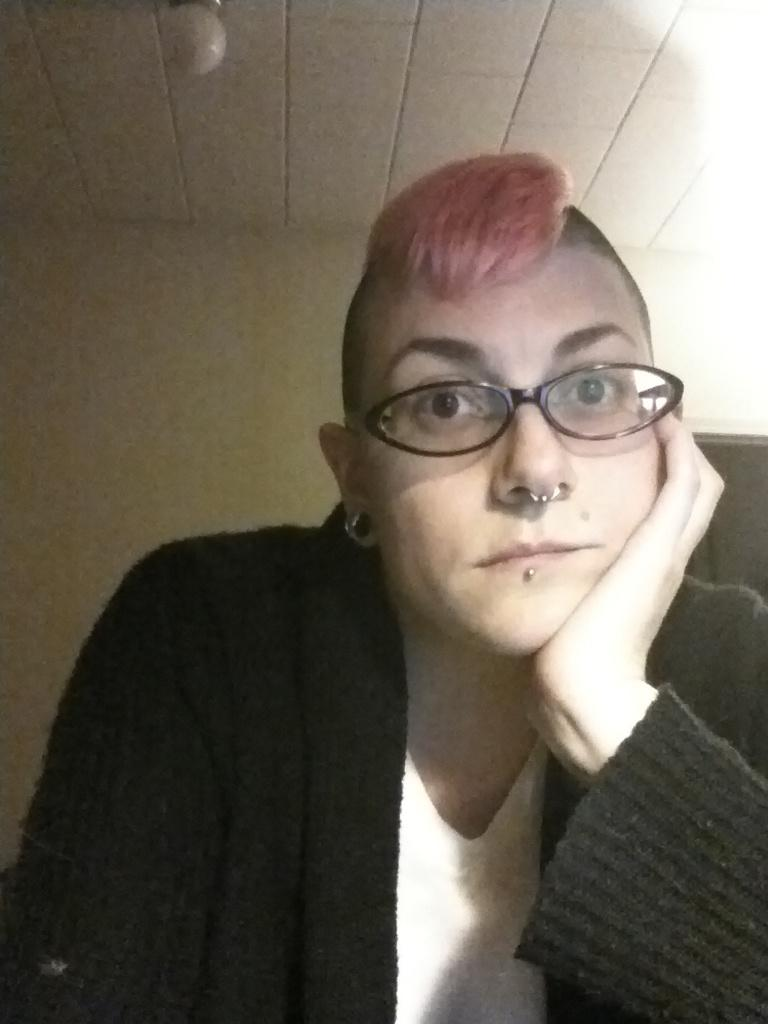What can be seen on the person's face in the image? There is a person with spectacles in the image. What type of lighting is present in the image? There is a ceiling light in the image. What is visible in the background of the image? There is a wall in the background of the image. How many books are on the person's self in the image? There is no mention of books or a self in the image; it only features a person with spectacles, a ceiling light, and a wall in the background. 